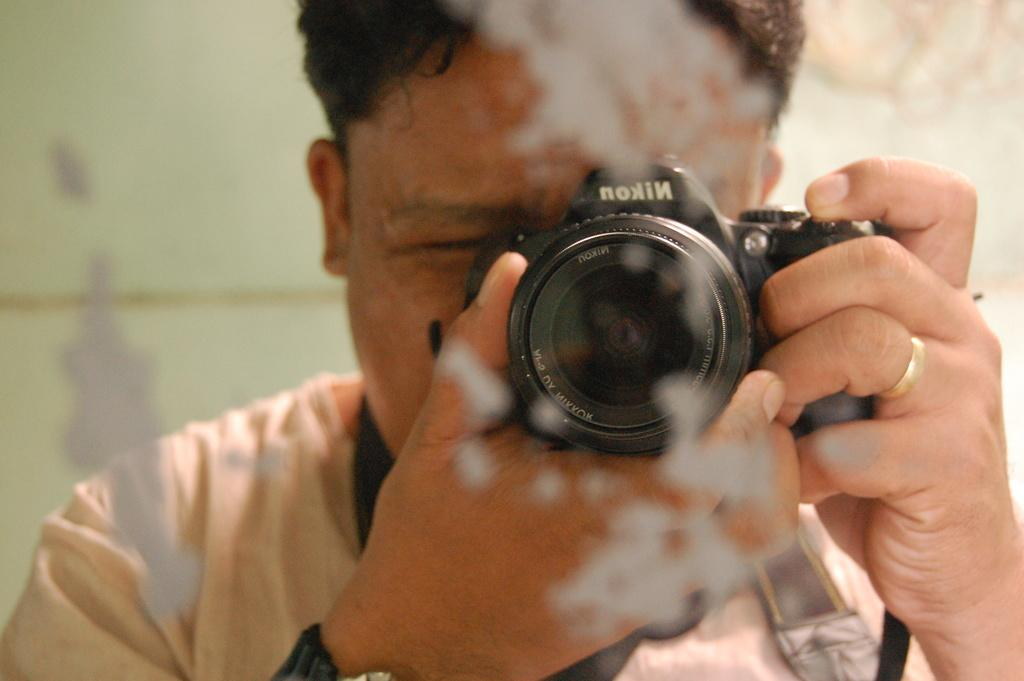Who is the main subject in the image? There is a man in the center of the image. What is the man doing in the image? The man is holding a camera and clicking pictures. What can be seen in the background of the image? There is a wall in the background of the image. What type of eggnog is the man drinking in the image? There is no eggnog present in the image; the man is holding a camera and clicking pictures. 